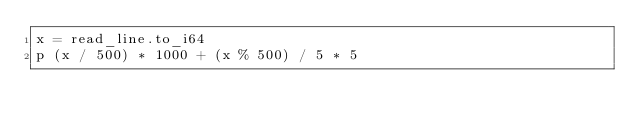<code> <loc_0><loc_0><loc_500><loc_500><_Crystal_>x = read_line.to_i64
p (x / 500) * 1000 + (x % 500) / 5 * 5</code> 